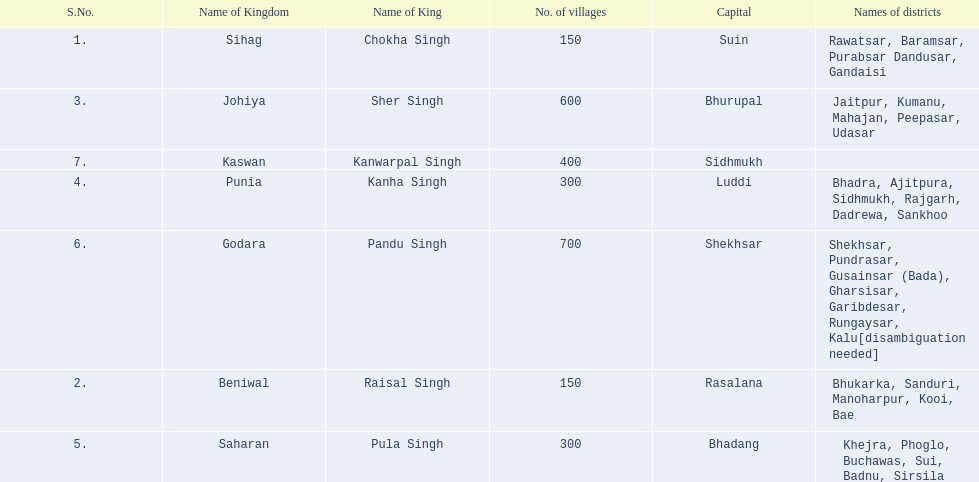Which kingdom contained the least amount of villages along with sihag? Beniwal. Which kingdom contained the most villages? Godara. Which village was tied at second most villages with godara? Johiya. 